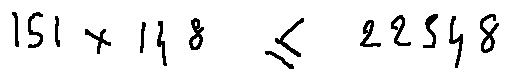<formula> <loc_0><loc_0><loc_500><loc_500>1 5 1 \times 1 4 8 \leq 2 2 3 4 8</formula> 